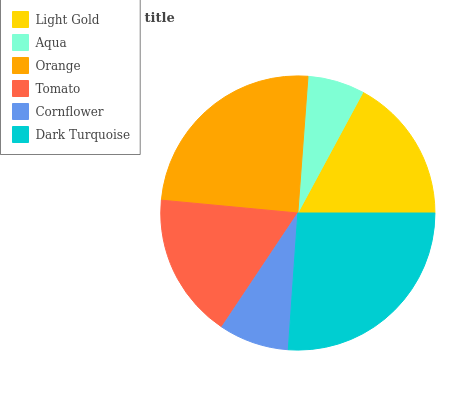Is Aqua the minimum?
Answer yes or no. Yes. Is Dark Turquoise the maximum?
Answer yes or no. Yes. Is Orange the minimum?
Answer yes or no. No. Is Orange the maximum?
Answer yes or no. No. Is Orange greater than Aqua?
Answer yes or no. Yes. Is Aqua less than Orange?
Answer yes or no. Yes. Is Aqua greater than Orange?
Answer yes or no. No. Is Orange less than Aqua?
Answer yes or no. No. Is Light Gold the high median?
Answer yes or no. Yes. Is Tomato the low median?
Answer yes or no. Yes. Is Tomato the high median?
Answer yes or no. No. Is Orange the low median?
Answer yes or no. No. 